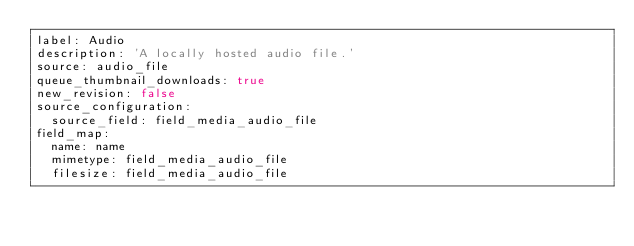Convert code to text. <code><loc_0><loc_0><loc_500><loc_500><_YAML_>label: Audio
description: 'A locally hosted audio file.'
source: audio_file
queue_thumbnail_downloads: true
new_revision: false
source_configuration:
  source_field: field_media_audio_file
field_map:
  name: name
  mimetype: field_media_audio_file
  filesize: field_media_audio_file
</code> 